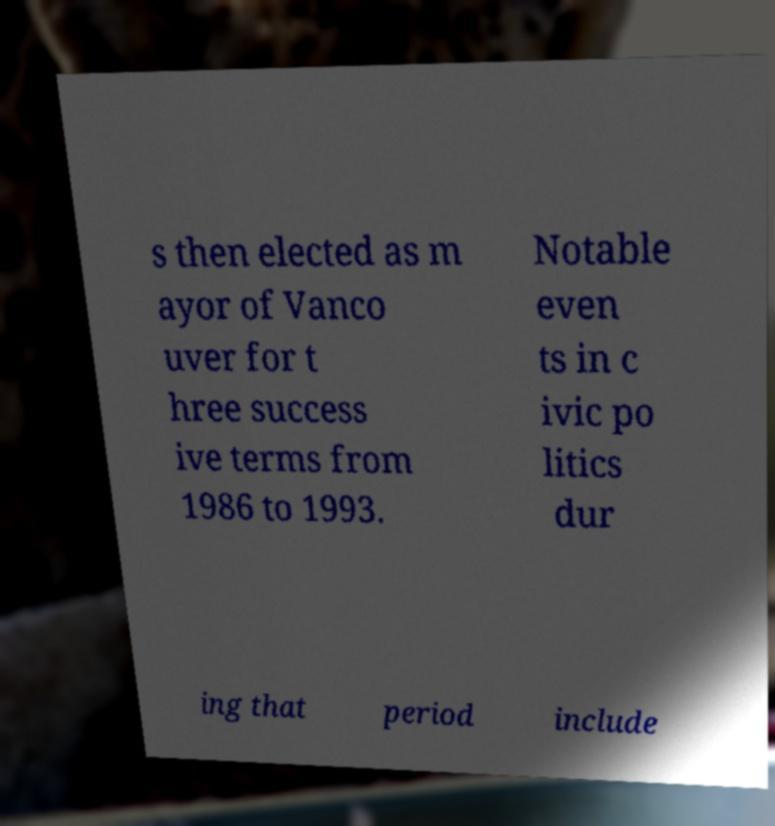There's text embedded in this image that I need extracted. Can you transcribe it verbatim? s then elected as m ayor of Vanco uver for t hree success ive terms from 1986 to 1993. Notable even ts in c ivic po litics dur ing that period include 